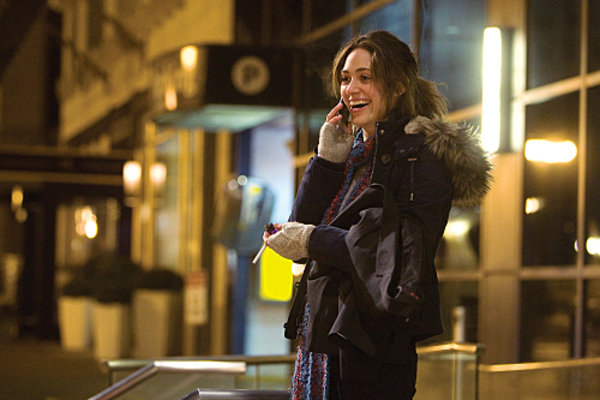Explain how her attire is suitable for the setting she is in. Her attire is perfectly suited for a chilly urban environment. The thick, fur-lined coat provides necessary warmth while the scarf adds an extra layer of protection against the cold. Her gloves not only serve a functional purpose to keep her hands warm but also add a touch of personal style to her outfit, suitable for a casual yet potentially stylish urban night out. 